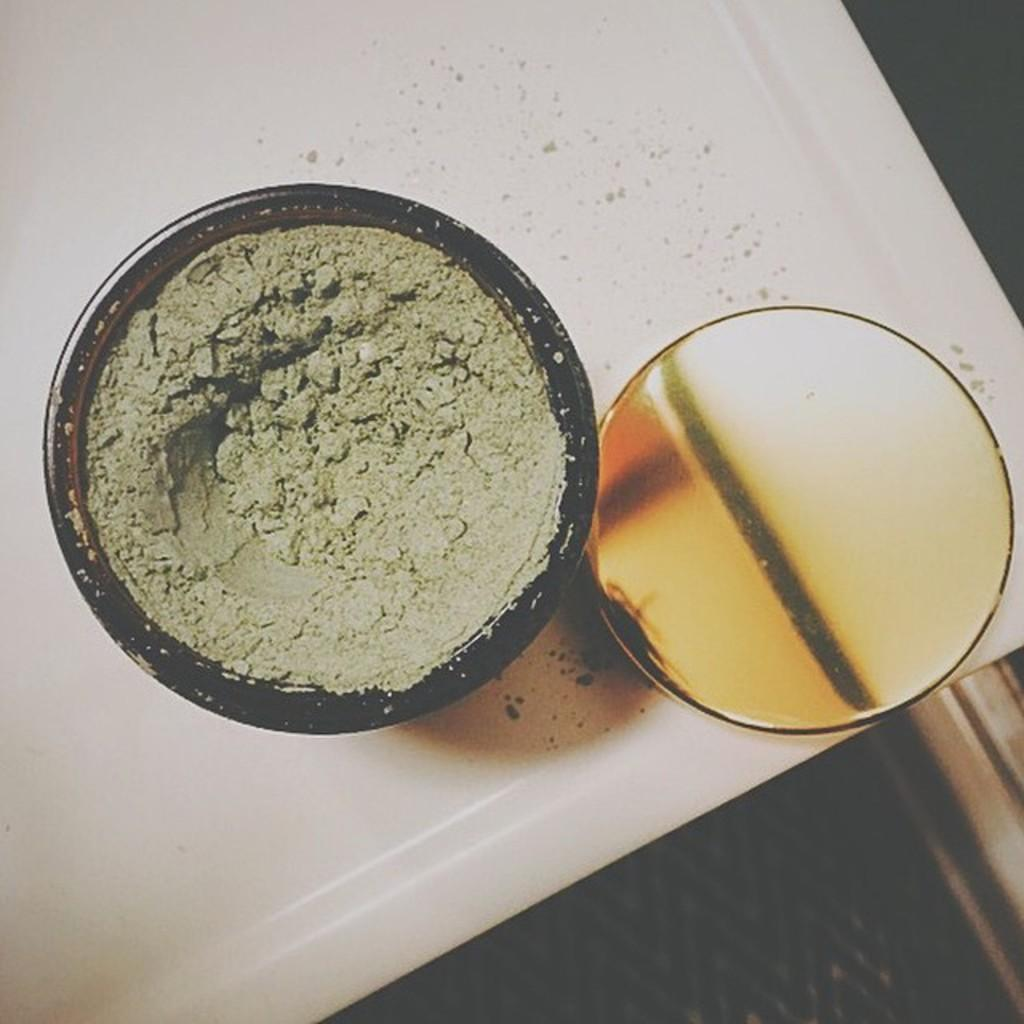What is in the bowl that is visible in the image? There is powder in a bowl in the image. What object can be seen on a white surface in the image? There is a mirror on a white surface in the image. What can be seen in the background of the image? The floor is visible in the background of the image. What type of secretary can be seen working in the image? There is no secretary present in the image. How does the powder react to the summer heat in the image? There is no indication of summer heat in the image, and the powder's reaction cannot be determined. 